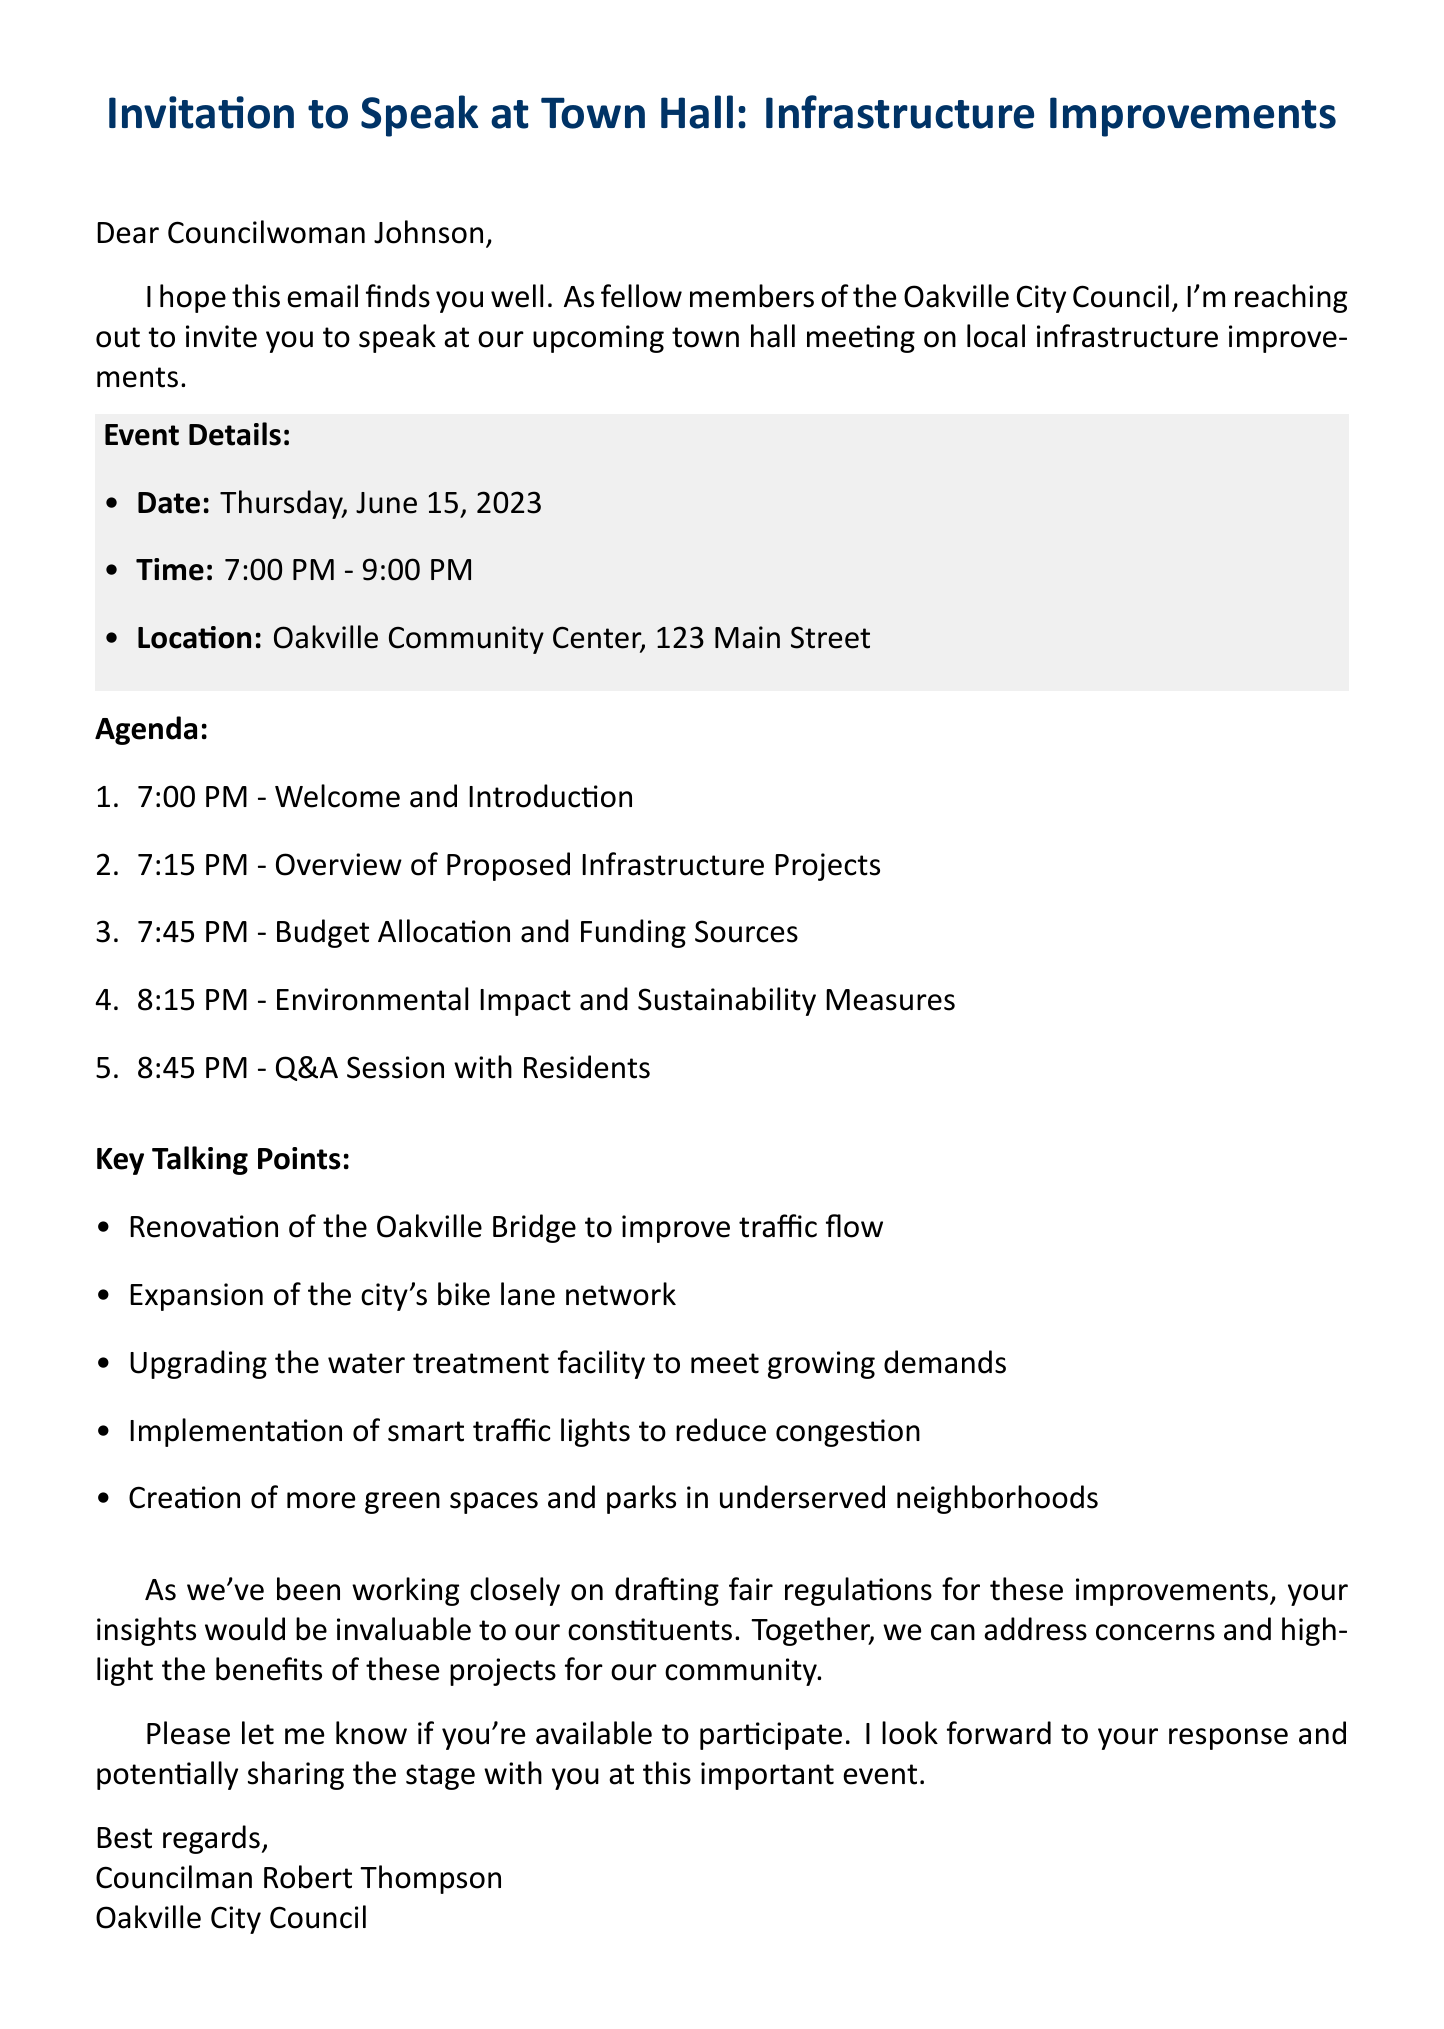What is the subject of the email? The subject line clearly states the purpose of the email, which is about an invitation regarding town hall infrastructure improvements.
Answer: Invitation to Speak at Town Hall: Infrastructure Improvements What is the date of the town hall meeting? The email specifies the date of the meeting in the event details section.
Answer: Thursday, June 15, 2023 Where is the event taking place? The location of the town hall meeting is provided in the event details.
Answer: Oakville Community Center, 123 Main Street What time does the meeting start? The starting time of the meeting is mentioned directly in the event details.
Answer: 7:00 PM What is one of the key talking points mentioned? The email lists several key talking points regarding infrastructure improvements.
Answer: Renovation of the Oakville Bridge to improve traffic flow How long is the Q&A session scheduled for? The agenda section specifies the time allotted for the Q&A session.
Answer: 8:45 PM - Q&A Session with Residents What role does Councilman Robert Thompson hold? The closing signature denotes the position of the sender in the city council.
Answer: Councilman Why is the collaboration mentioned in the email? The email explains the importance of insights for addressing community concerns through collaboration.
Answer: To address concerns and highlight the benefits of these projects for our community 